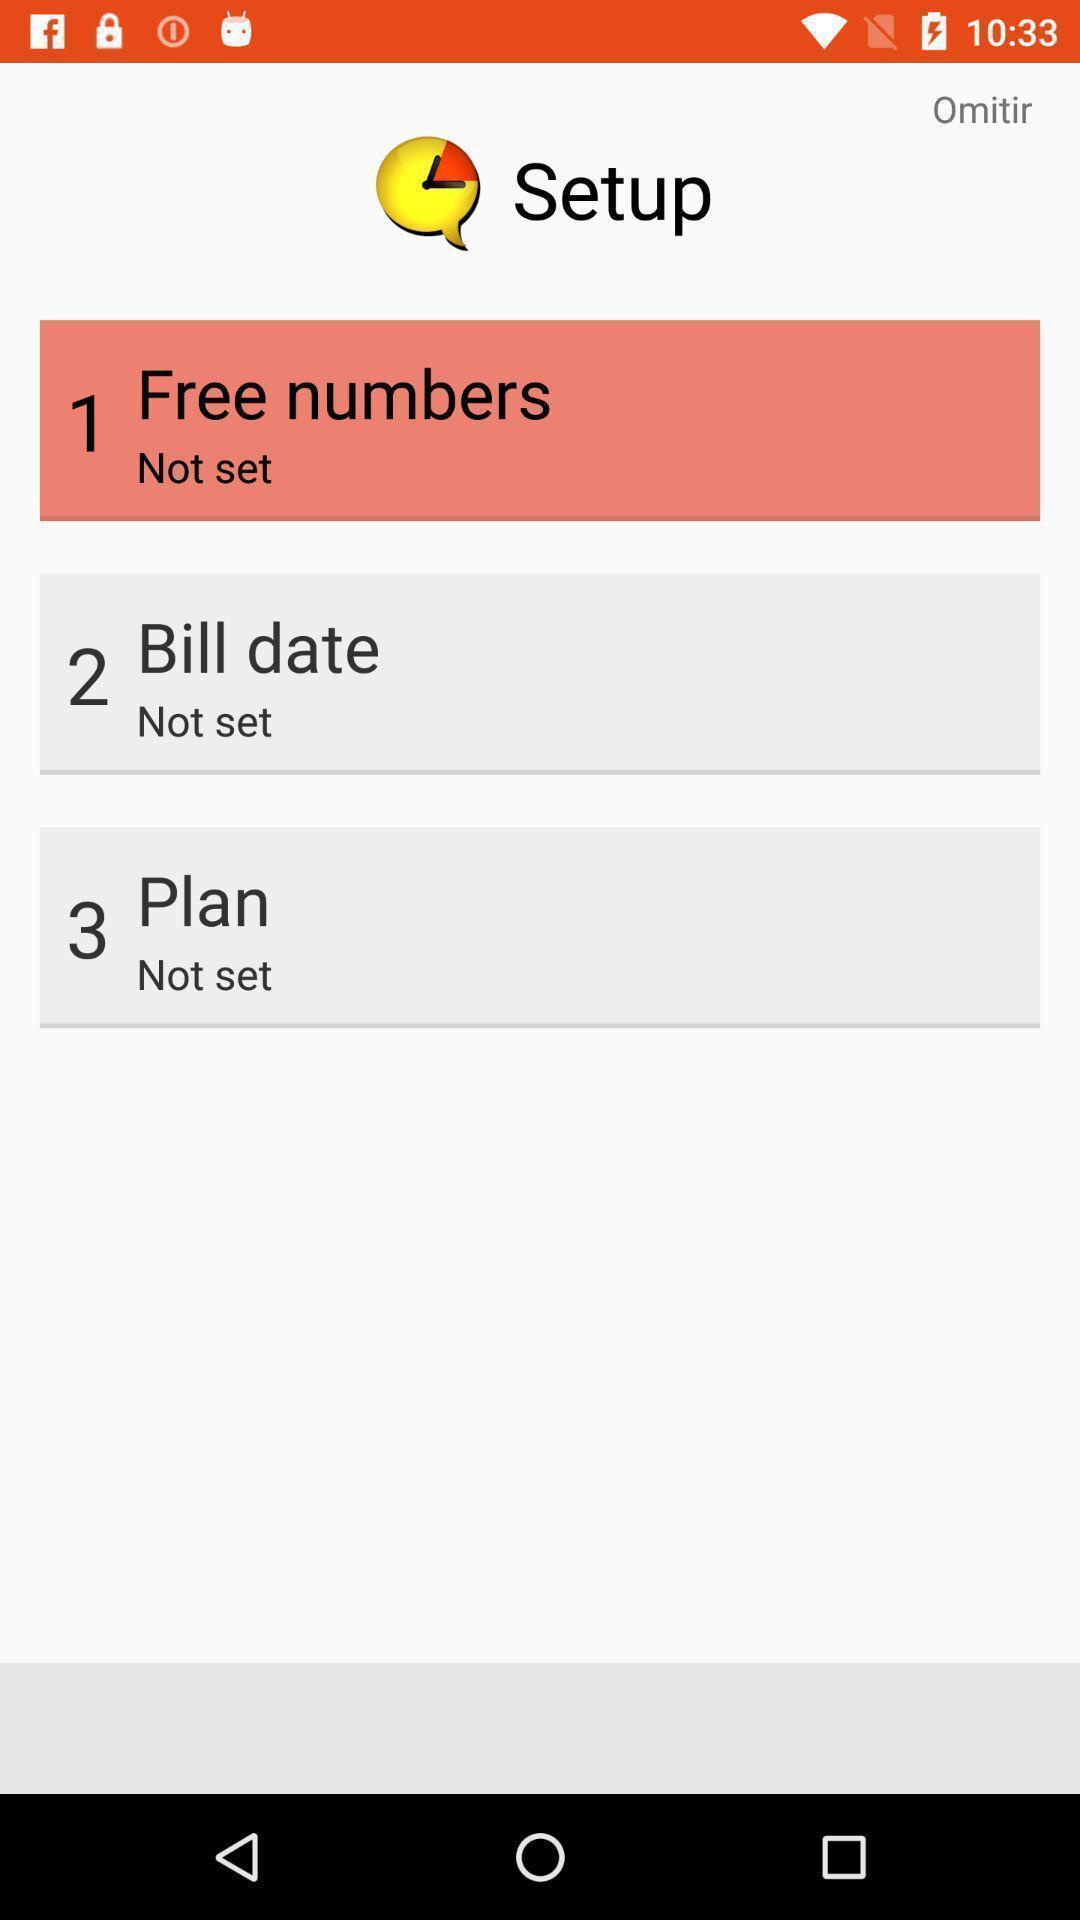What details can you identify in this image? Screen displaying the welcome page of learning app. 